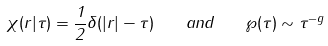<formula> <loc_0><loc_0><loc_500><loc_500>\chi ( r | \tau ) = \frac { 1 } { 2 } \delta ( | r | - \tau ) \quad a n d \quad \wp ( \tau ) \sim \tau ^ { - g }</formula> 